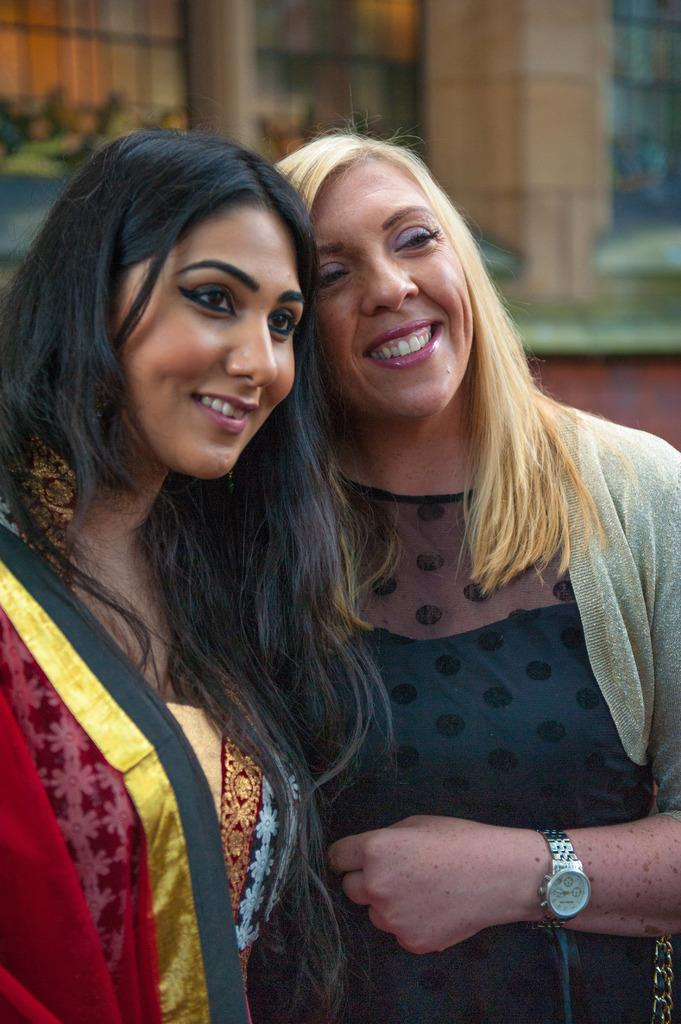How many people are present in the image? There are two people in the image. What can be seen in the background of the image? There is a wall in the background of the image. What type of hat is the baseball player wearing in the image? There is no baseball player or hat present in the image. How many thumbs does the person on the left have in the image? We cannot determine the number of thumbs the person has in the image based on the provided facts. 